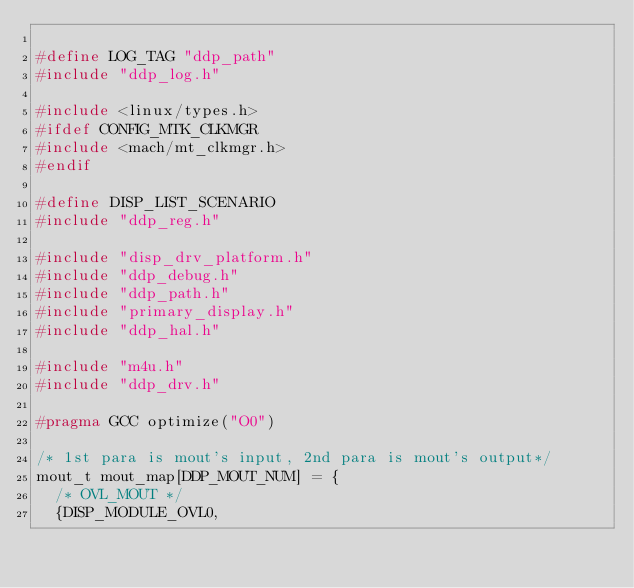Convert code to text. <code><loc_0><loc_0><loc_500><loc_500><_C_>
#define LOG_TAG "ddp_path"
#include "ddp_log.h"

#include <linux/types.h>
#ifdef CONFIG_MTK_CLKMGR
#include <mach/mt_clkmgr.h>
#endif

#define DISP_LIST_SCENARIO
#include "ddp_reg.h"

#include "disp_drv_platform.h"
#include "ddp_debug.h"
#include "ddp_path.h"
#include "primary_display.h"
#include "ddp_hal.h"

#include "m4u.h"
#include "ddp_drv.h"

#pragma GCC optimize("O0")

/* 1st para is mout's input, 2nd para is mout's output*/
mout_t mout_map[DDP_MOUT_NUM] = {
	/* OVL_MOUT */
	{DISP_MODULE_OVL0,</code> 